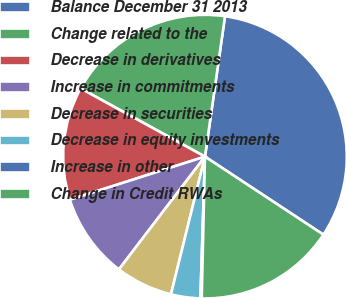<chart> <loc_0><loc_0><loc_500><loc_500><pie_chart><fcel>Balance December 31 2013<fcel>Change related to the<fcel>Decrease in derivatives<fcel>Increase in commitments<fcel>Decrease in securities<fcel>Decrease in equity investments<fcel>Increase in other<fcel>Change in Credit RWAs<nl><fcel>32.02%<fcel>19.27%<fcel>12.9%<fcel>9.71%<fcel>6.52%<fcel>3.34%<fcel>0.15%<fcel>16.09%<nl></chart> 